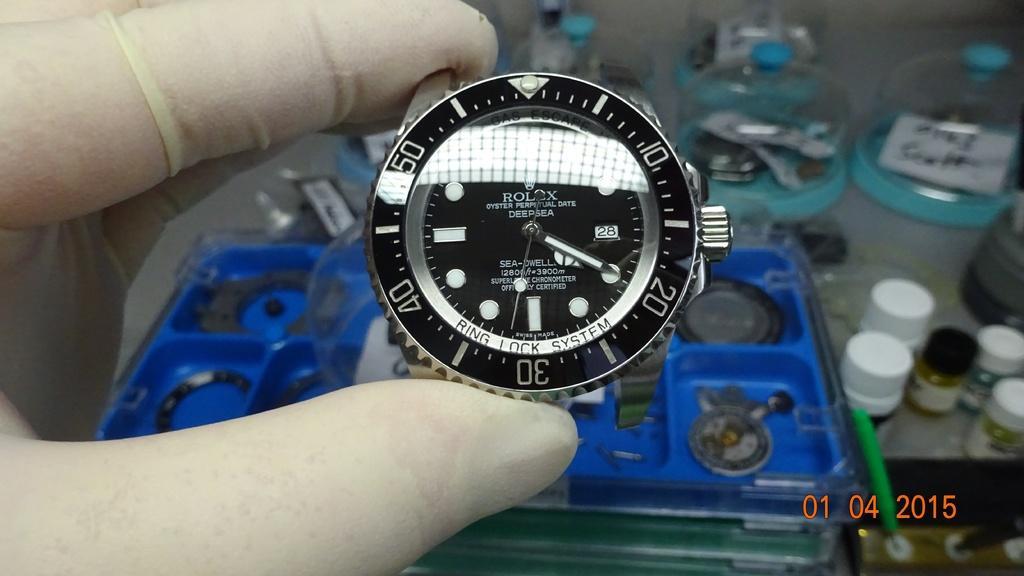Could you give a brief overview of what you see in this image? A human hand is holding the Rolex watch, it is in black color. 